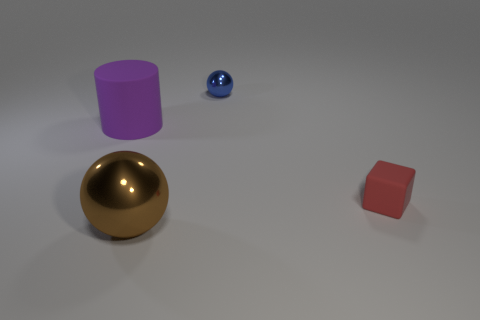How would you describe the composition and balance of the image? The composition is simple and balanced with negative space. Objects are arranged asymmetrically but with a sense of equilibrium. The large golden sphere at the bottom left anchors the image visually, while the smaller objects balance the composition through their placement across the frame. 